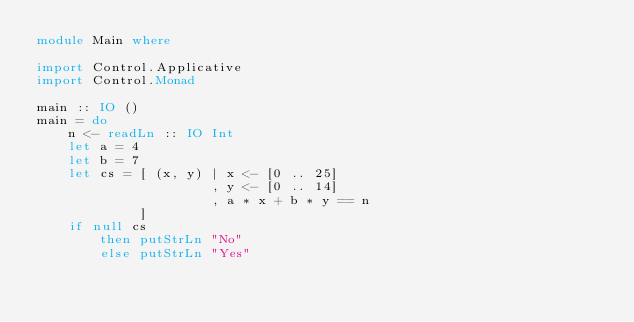<code> <loc_0><loc_0><loc_500><loc_500><_Haskell_>module Main where

import Control.Applicative
import Control.Monad

main :: IO ()
main = do
    n <- readLn :: IO Int
    let a = 4
    let b = 7
    let cs = [ (x, y) | x <- [0 .. 25]
                      , y <- [0 .. 14]
                      , a * x + b * y == n
             ]
    if null cs
        then putStrLn "No"
        else putStrLn "Yes"</code> 